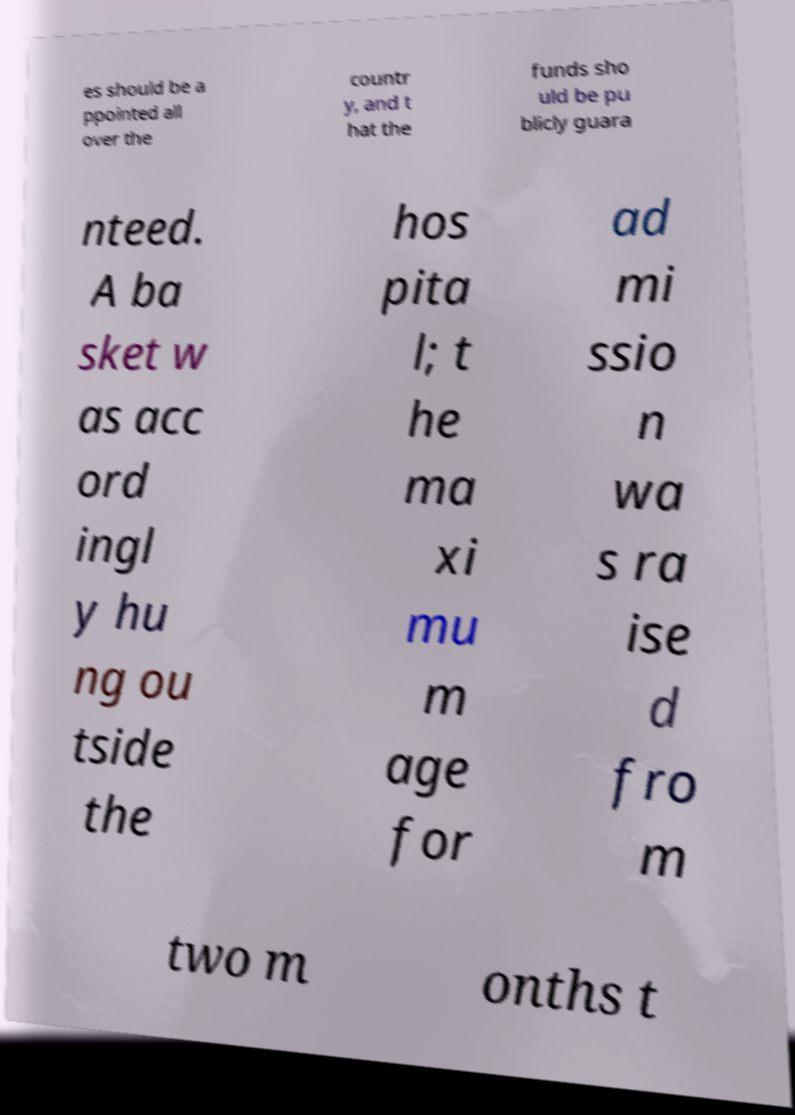Please identify and transcribe the text found in this image. es should be a ppointed all over the countr y, and t hat the funds sho uld be pu blicly guara nteed. A ba sket w as acc ord ingl y hu ng ou tside the hos pita l; t he ma xi mu m age for ad mi ssio n wa s ra ise d fro m two m onths t 